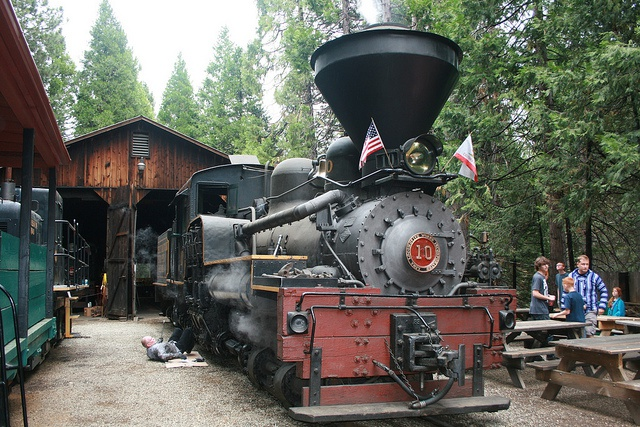Describe the objects in this image and their specific colors. I can see train in maroon, black, gray, darkgray, and brown tones, train in maroon, black, teal, gray, and darkblue tones, bench in maroon, black, gray, and darkgray tones, dining table in maroon, black, gray, and darkgray tones, and bench in maroon, black, gray, darkgray, and lightgray tones in this image. 